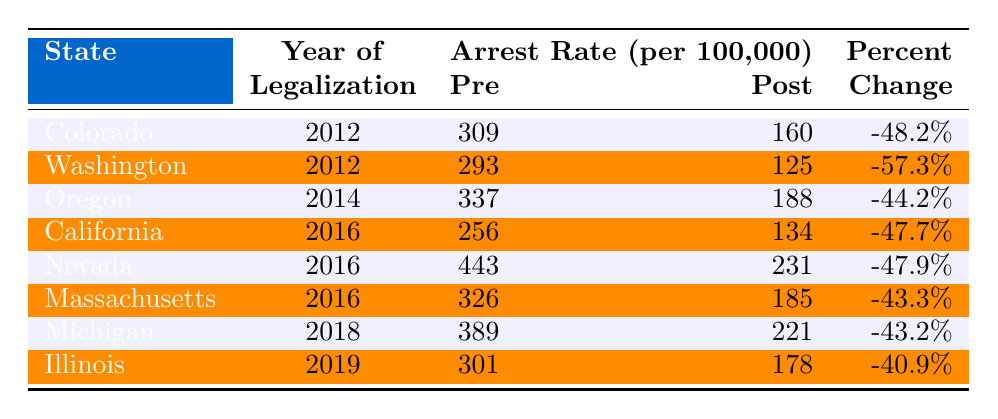What was the arrest rate in Colorado before legalization? According to the table, the Pre-Legalization Arrest Rate in Colorado was 309 per 100,000.
Answer: 309 What is the Percent Change in the arrest rate for Washington after legalization? The table shows that the Percent Change in the arrest rate for Washington is -57.3%.
Answer: -57.3% Which state had the highest arrest rate before legalization? By comparing the Pre-Legalization Arrest Rates in the table, Nevada had the highest rate at 443 per 100,000.
Answer: Nevada What is the difference between pre-legalization and post-legalization arrest rates in California? The Pre-Legalization arrest rate in California was 256, and the Post-Legalization rate was 134. The difference is 256 - 134 = 122.
Answer: 122 Which state experienced the smallest reduction percentage in arrest rates post-legalization? Looking at the Percent Change column, Illinois saw the smallest reduction at -40.9%.
Answer: Illinois How many states had a post-legalization arrest rate lower than 200 per 100,000? In checking the Post-Legalization Arrest Rates, Oregon, California, Nevada, Massachusetts, and Michigan had rates below 200. That totals 5 states.
Answer: 5 What was the average pre-legalization arrest rate across all states listed? Adding the Pre-Legalization rates: 309 + 293 + 337 + 256 + 443 + 326 + 389 + 301 = 2634. Dividing by 8 states gives an average of 2634 / 8 = 329.25.
Answer: 329.25 Is the percent change in Oregon greater in magnitude than that in Massachusetts? The Percent Change for Oregon is -44.2% and for Massachusetts is -43.3%. Since -44.2% is greater in magnitude than -43.3%, the statement is true.
Answer: Yes How many years after legalization did Illinois report its arrest rate change? Illinois legalized cannabis in 2019, and thus its rate change is reported in the same year. Therefore, it is 0 years after legalization.
Answer: 0 What was the total reduction in arrest rates (pre-legalization vs. post-legalization) for all listed states? To find the total reduction, we sum the differences for each state: (309 - 160) + (293 - 125) + (337 - 188) + (256 - 134) + (443 - 231) + (326 - 185) + (389 - 221) + (301 - 178) = 149 + 168 + 149 + 122 + 212 + 141 + 168 + 123 = 1082 total reduction.
Answer: 1082 